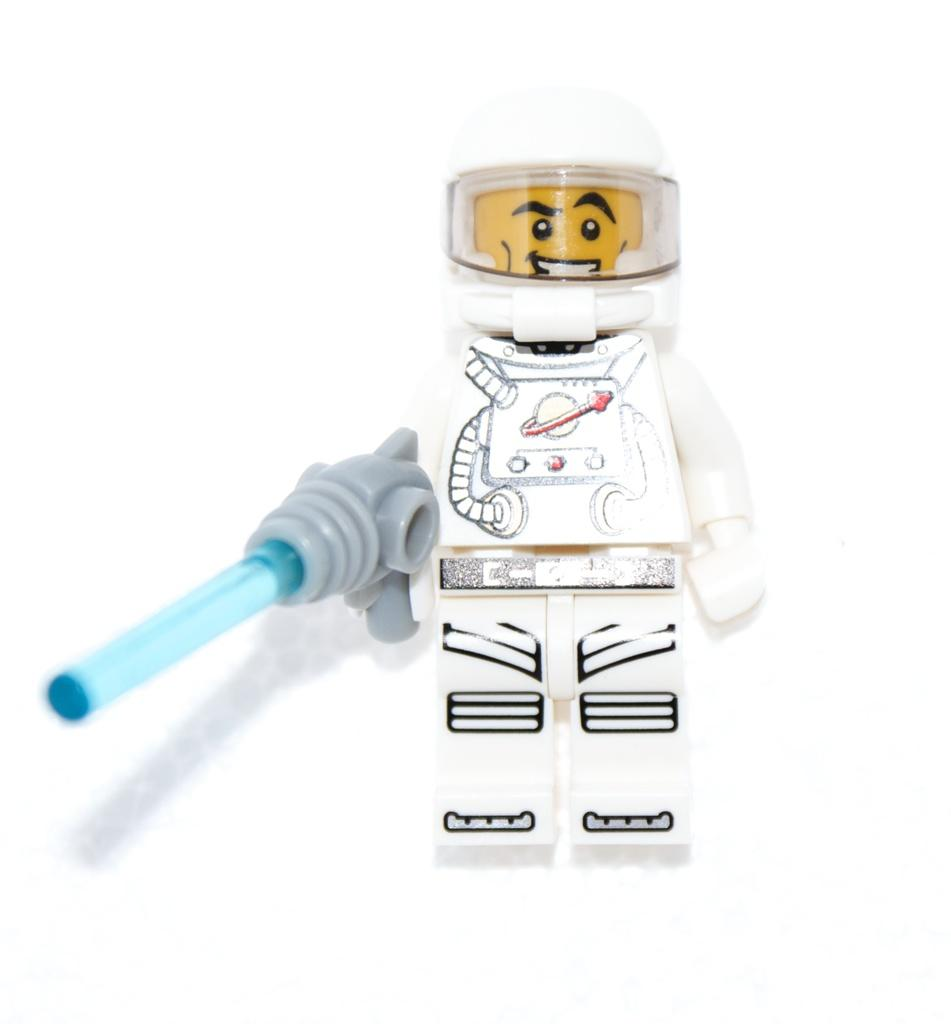What shape is the toy in the image? The toy is in the shape of an astronaut. What color is the astronaut toy? The toy is white in color. Is the astronaut toy wearing a veil in the image? There is no veil present on the astronaut toy in the image. Can you tell me how many snakes are visible in the image? There are no snakes present in the image; it features an astronaut toy. 